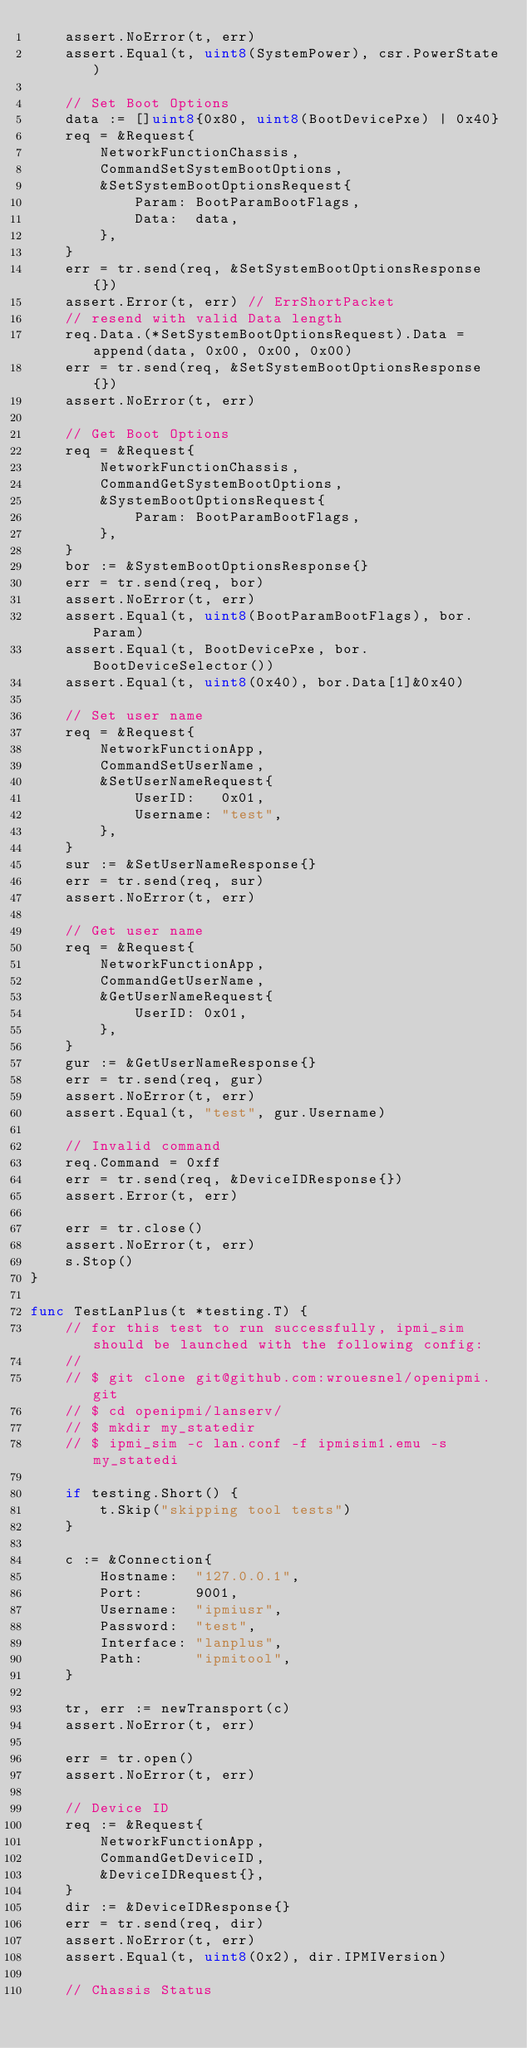<code> <loc_0><loc_0><loc_500><loc_500><_Go_>	assert.NoError(t, err)
	assert.Equal(t, uint8(SystemPower), csr.PowerState)

	// Set Boot Options
	data := []uint8{0x80, uint8(BootDevicePxe) | 0x40}
	req = &Request{
		NetworkFunctionChassis,
		CommandSetSystemBootOptions,
		&SetSystemBootOptionsRequest{
			Param: BootParamBootFlags,
			Data:  data,
		},
	}
	err = tr.send(req, &SetSystemBootOptionsResponse{})
	assert.Error(t, err) // ErrShortPacket
	// resend with valid Data length
	req.Data.(*SetSystemBootOptionsRequest).Data = append(data, 0x00, 0x00, 0x00)
	err = tr.send(req, &SetSystemBootOptionsResponse{})
	assert.NoError(t, err)

	// Get Boot Options
	req = &Request{
		NetworkFunctionChassis,
		CommandGetSystemBootOptions,
		&SystemBootOptionsRequest{
			Param: BootParamBootFlags,
		},
	}
	bor := &SystemBootOptionsResponse{}
	err = tr.send(req, bor)
	assert.NoError(t, err)
	assert.Equal(t, uint8(BootParamBootFlags), bor.Param)
	assert.Equal(t, BootDevicePxe, bor.BootDeviceSelector())
	assert.Equal(t, uint8(0x40), bor.Data[1]&0x40)

	// Set user name
	req = &Request{
		NetworkFunctionApp,
		CommandSetUserName,
		&SetUserNameRequest{
			UserID:   0x01,
			Username: "test",
		},
	}
	sur := &SetUserNameResponse{}
	err = tr.send(req, sur)
	assert.NoError(t, err)

	// Get user name
	req = &Request{
		NetworkFunctionApp,
		CommandGetUserName,
		&GetUserNameRequest{
			UserID: 0x01,
		},
	}
	gur := &GetUserNameResponse{}
	err = tr.send(req, gur)
	assert.NoError(t, err)
	assert.Equal(t, "test", gur.Username)

	// Invalid command
	req.Command = 0xff
	err = tr.send(req, &DeviceIDResponse{})
	assert.Error(t, err)

	err = tr.close()
	assert.NoError(t, err)
	s.Stop()
}

func TestLanPlus(t *testing.T) {
	// for this test to run successfully, ipmi_sim should be launched with the following config:
	//
	// $ git clone git@github.com:wrouesnel/openipmi.git
	// $ cd openipmi/lanserv/
	// $ mkdir my_statedir
	// $ ipmi_sim -c lan.conf -f ipmisim1.emu -s my_statedi

	if testing.Short() {
		t.Skip("skipping tool tests")
	}

	c := &Connection{
		Hostname:  "127.0.0.1",
		Port:      9001,
		Username:  "ipmiusr",
		Password:  "test",
		Interface: "lanplus",
		Path:      "ipmitool",
	}

	tr, err := newTransport(c)
	assert.NoError(t, err)

	err = tr.open()
	assert.NoError(t, err)

	// Device ID
	req := &Request{
		NetworkFunctionApp,
		CommandGetDeviceID,
		&DeviceIDRequest{},
	}
	dir := &DeviceIDResponse{}
	err = tr.send(req, dir)
	assert.NoError(t, err)
	assert.Equal(t, uint8(0x2), dir.IPMIVersion)

	// Chassis Status</code> 